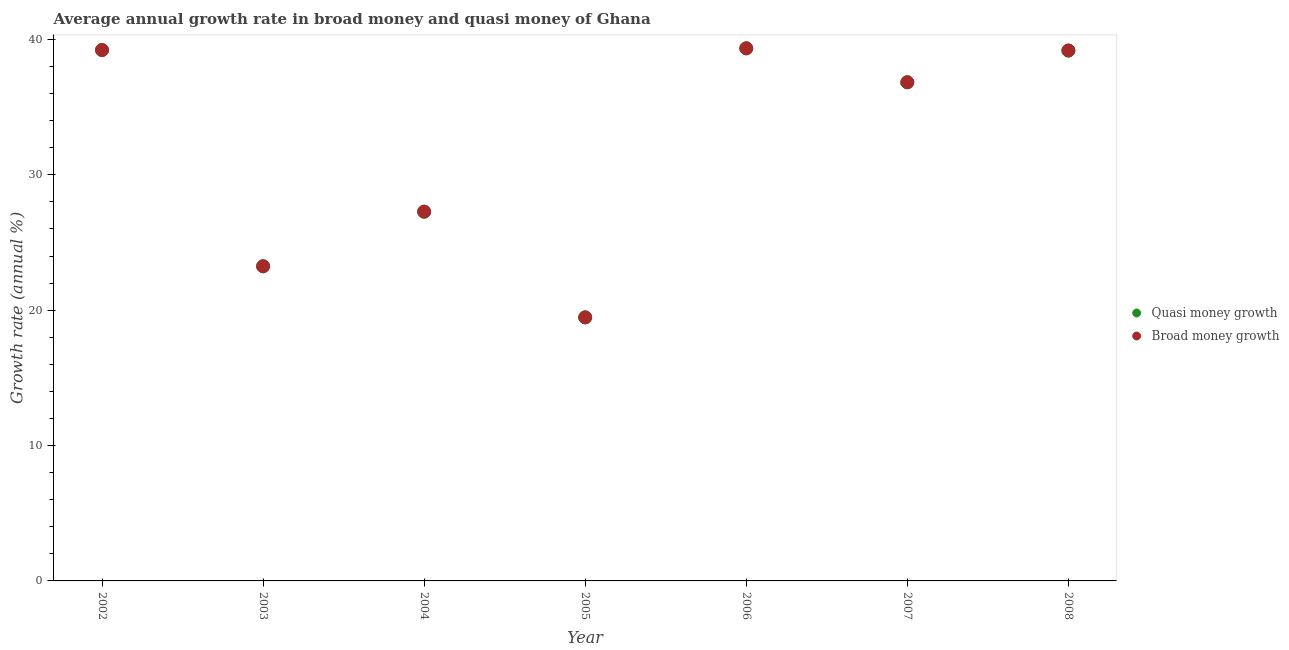How many different coloured dotlines are there?
Offer a very short reply. 2. Is the number of dotlines equal to the number of legend labels?
Offer a terse response. Yes. What is the annual growth rate in quasi money in 2003?
Make the answer very short. 23.24. Across all years, what is the maximum annual growth rate in broad money?
Offer a very short reply. 39.34. Across all years, what is the minimum annual growth rate in quasi money?
Offer a very short reply. 19.47. In which year was the annual growth rate in broad money maximum?
Keep it short and to the point. 2006. What is the total annual growth rate in quasi money in the graph?
Offer a terse response. 224.55. What is the difference between the annual growth rate in broad money in 2006 and that in 2008?
Provide a succinct answer. 0.16. What is the difference between the annual growth rate in quasi money in 2006 and the annual growth rate in broad money in 2008?
Offer a very short reply. 0.16. What is the average annual growth rate in quasi money per year?
Offer a terse response. 32.08. In the year 2005, what is the difference between the annual growth rate in broad money and annual growth rate in quasi money?
Make the answer very short. 0. What is the ratio of the annual growth rate in quasi money in 2005 to that in 2007?
Your answer should be very brief. 0.53. Is the difference between the annual growth rate in quasi money in 2005 and 2006 greater than the difference between the annual growth rate in broad money in 2005 and 2006?
Offer a terse response. No. What is the difference between the highest and the second highest annual growth rate in quasi money?
Offer a very short reply. 0.13. What is the difference between the highest and the lowest annual growth rate in quasi money?
Your answer should be compact. 19.87. In how many years, is the annual growth rate in quasi money greater than the average annual growth rate in quasi money taken over all years?
Ensure brevity in your answer.  4. Is the annual growth rate in broad money strictly greater than the annual growth rate in quasi money over the years?
Make the answer very short. No. Is the annual growth rate in quasi money strictly less than the annual growth rate in broad money over the years?
Make the answer very short. No. How many dotlines are there?
Keep it short and to the point. 2. How many years are there in the graph?
Your response must be concise. 7. Does the graph contain grids?
Your answer should be very brief. No. Where does the legend appear in the graph?
Your response must be concise. Center right. What is the title of the graph?
Provide a succinct answer. Average annual growth rate in broad money and quasi money of Ghana. What is the label or title of the X-axis?
Offer a terse response. Year. What is the label or title of the Y-axis?
Give a very brief answer. Growth rate (annual %). What is the Growth rate (annual %) in Quasi money growth in 2002?
Make the answer very short. 39.21. What is the Growth rate (annual %) in Broad money growth in 2002?
Ensure brevity in your answer.  39.21. What is the Growth rate (annual %) in Quasi money growth in 2003?
Give a very brief answer. 23.24. What is the Growth rate (annual %) in Broad money growth in 2003?
Provide a succinct answer. 23.24. What is the Growth rate (annual %) in Quasi money growth in 2004?
Ensure brevity in your answer.  27.28. What is the Growth rate (annual %) of Broad money growth in 2004?
Provide a succinct answer. 27.28. What is the Growth rate (annual %) of Quasi money growth in 2005?
Offer a terse response. 19.47. What is the Growth rate (annual %) of Broad money growth in 2005?
Your answer should be very brief. 19.47. What is the Growth rate (annual %) of Quasi money growth in 2006?
Your response must be concise. 39.34. What is the Growth rate (annual %) of Broad money growth in 2006?
Keep it short and to the point. 39.34. What is the Growth rate (annual %) in Quasi money growth in 2007?
Provide a short and direct response. 36.83. What is the Growth rate (annual %) of Broad money growth in 2007?
Your response must be concise. 36.83. What is the Growth rate (annual %) of Quasi money growth in 2008?
Ensure brevity in your answer.  39.18. What is the Growth rate (annual %) of Broad money growth in 2008?
Offer a terse response. 39.18. Across all years, what is the maximum Growth rate (annual %) of Quasi money growth?
Your response must be concise. 39.34. Across all years, what is the maximum Growth rate (annual %) of Broad money growth?
Keep it short and to the point. 39.34. Across all years, what is the minimum Growth rate (annual %) in Quasi money growth?
Provide a short and direct response. 19.47. Across all years, what is the minimum Growth rate (annual %) of Broad money growth?
Provide a short and direct response. 19.47. What is the total Growth rate (annual %) of Quasi money growth in the graph?
Your answer should be compact. 224.55. What is the total Growth rate (annual %) in Broad money growth in the graph?
Ensure brevity in your answer.  224.55. What is the difference between the Growth rate (annual %) in Quasi money growth in 2002 and that in 2003?
Your response must be concise. 15.97. What is the difference between the Growth rate (annual %) in Broad money growth in 2002 and that in 2003?
Offer a very short reply. 15.97. What is the difference between the Growth rate (annual %) of Quasi money growth in 2002 and that in 2004?
Offer a very short reply. 11.94. What is the difference between the Growth rate (annual %) of Broad money growth in 2002 and that in 2004?
Your response must be concise. 11.94. What is the difference between the Growth rate (annual %) in Quasi money growth in 2002 and that in 2005?
Give a very brief answer. 19.75. What is the difference between the Growth rate (annual %) of Broad money growth in 2002 and that in 2005?
Give a very brief answer. 19.75. What is the difference between the Growth rate (annual %) in Quasi money growth in 2002 and that in 2006?
Keep it short and to the point. -0.13. What is the difference between the Growth rate (annual %) in Broad money growth in 2002 and that in 2006?
Keep it short and to the point. -0.13. What is the difference between the Growth rate (annual %) in Quasi money growth in 2002 and that in 2007?
Keep it short and to the point. 2.38. What is the difference between the Growth rate (annual %) of Broad money growth in 2002 and that in 2007?
Provide a short and direct response. 2.38. What is the difference between the Growth rate (annual %) of Quasi money growth in 2002 and that in 2008?
Make the answer very short. 0.04. What is the difference between the Growth rate (annual %) in Broad money growth in 2002 and that in 2008?
Provide a succinct answer. 0.04. What is the difference between the Growth rate (annual %) in Quasi money growth in 2003 and that in 2004?
Your answer should be very brief. -4.03. What is the difference between the Growth rate (annual %) of Broad money growth in 2003 and that in 2004?
Give a very brief answer. -4.03. What is the difference between the Growth rate (annual %) in Quasi money growth in 2003 and that in 2005?
Keep it short and to the point. 3.77. What is the difference between the Growth rate (annual %) of Broad money growth in 2003 and that in 2005?
Your answer should be very brief. 3.77. What is the difference between the Growth rate (annual %) of Quasi money growth in 2003 and that in 2006?
Keep it short and to the point. -16.1. What is the difference between the Growth rate (annual %) in Broad money growth in 2003 and that in 2006?
Ensure brevity in your answer.  -16.1. What is the difference between the Growth rate (annual %) of Quasi money growth in 2003 and that in 2007?
Keep it short and to the point. -13.59. What is the difference between the Growth rate (annual %) in Broad money growth in 2003 and that in 2007?
Provide a short and direct response. -13.59. What is the difference between the Growth rate (annual %) of Quasi money growth in 2003 and that in 2008?
Give a very brief answer. -15.94. What is the difference between the Growth rate (annual %) in Broad money growth in 2003 and that in 2008?
Provide a short and direct response. -15.94. What is the difference between the Growth rate (annual %) in Quasi money growth in 2004 and that in 2005?
Give a very brief answer. 7.81. What is the difference between the Growth rate (annual %) of Broad money growth in 2004 and that in 2005?
Give a very brief answer. 7.81. What is the difference between the Growth rate (annual %) of Quasi money growth in 2004 and that in 2006?
Ensure brevity in your answer.  -12.07. What is the difference between the Growth rate (annual %) in Broad money growth in 2004 and that in 2006?
Offer a very short reply. -12.07. What is the difference between the Growth rate (annual %) in Quasi money growth in 2004 and that in 2007?
Offer a terse response. -9.56. What is the difference between the Growth rate (annual %) in Broad money growth in 2004 and that in 2007?
Give a very brief answer. -9.56. What is the difference between the Growth rate (annual %) of Quasi money growth in 2004 and that in 2008?
Your answer should be very brief. -11.9. What is the difference between the Growth rate (annual %) in Broad money growth in 2004 and that in 2008?
Your response must be concise. -11.9. What is the difference between the Growth rate (annual %) in Quasi money growth in 2005 and that in 2006?
Your answer should be very brief. -19.87. What is the difference between the Growth rate (annual %) of Broad money growth in 2005 and that in 2006?
Offer a terse response. -19.87. What is the difference between the Growth rate (annual %) in Quasi money growth in 2005 and that in 2007?
Provide a succinct answer. -17.37. What is the difference between the Growth rate (annual %) of Broad money growth in 2005 and that in 2007?
Provide a short and direct response. -17.37. What is the difference between the Growth rate (annual %) in Quasi money growth in 2005 and that in 2008?
Give a very brief answer. -19.71. What is the difference between the Growth rate (annual %) in Broad money growth in 2005 and that in 2008?
Your answer should be very brief. -19.71. What is the difference between the Growth rate (annual %) of Quasi money growth in 2006 and that in 2007?
Keep it short and to the point. 2.51. What is the difference between the Growth rate (annual %) in Broad money growth in 2006 and that in 2007?
Keep it short and to the point. 2.51. What is the difference between the Growth rate (annual %) of Quasi money growth in 2006 and that in 2008?
Give a very brief answer. 0.16. What is the difference between the Growth rate (annual %) in Broad money growth in 2006 and that in 2008?
Ensure brevity in your answer.  0.16. What is the difference between the Growth rate (annual %) in Quasi money growth in 2007 and that in 2008?
Keep it short and to the point. -2.34. What is the difference between the Growth rate (annual %) in Broad money growth in 2007 and that in 2008?
Make the answer very short. -2.34. What is the difference between the Growth rate (annual %) of Quasi money growth in 2002 and the Growth rate (annual %) of Broad money growth in 2003?
Keep it short and to the point. 15.97. What is the difference between the Growth rate (annual %) in Quasi money growth in 2002 and the Growth rate (annual %) in Broad money growth in 2004?
Offer a very short reply. 11.94. What is the difference between the Growth rate (annual %) in Quasi money growth in 2002 and the Growth rate (annual %) in Broad money growth in 2005?
Offer a very short reply. 19.75. What is the difference between the Growth rate (annual %) of Quasi money growth in 2002 and the Growth rate (annual %) of Broad money growth in 2006?
Keep it short and to the point. -0.13. What is the difference between the Growth rate (annual %) in Quasi money growth in 2002 and the Growth rate (annual %) in Broad money growth in 2007?
Offer a terse response. 2.38. What is the difference between the Growth rate (annual %) in Quasi money growth in 2002 and the Growth rate (annual %) in Broad money growth in 2008?
Give a very brief answer. 0.04. What is the difference between the Growth rate (annual %) of Quasi money growth in 2003 and the Growth rate (annual %) of Broad money growth in 2004?
Your answer should be compact. -4.03. What is the difference between the Growth rate (annual %) in Quasi money growth in 2003 and the Growth rate (annual %) in Broad money growth in 2005?
Make the answer very short. 3.77. What is the difference between the Growth rate (annual %) of Quasi money growth in 2003 and the Growth rate (annual %) of Broad money growth in 2006?
Provide a succinct answer. -16.1. What is the difference between the Growth rate (annual %) of Quasi money growth in 2003 and the Growth rate (annual %) of Broad money growth in 2007?
Your response must be concise. -13.59. What is the difference between the Growth rate (annual %) in Quasi money growth in 2003 and the Growth rate (annual %) in Broad money growth in 2008?
Give a very brief answer. -15.94. What is the difference between the Growth rate (annual %) of Quasi money growth in 2004 and the Growth rate (annual %) of Broad money growth in 2005?
Offer a very short reply. 7.81. What is the difference between the Growth rate (annual %) in Quasi money growth in 2004 and the Growth rate (annual %) in Broad money growth in 2006?
Provide a short and direct response. -12.07. What is the difference between the Growth rate (annual %) of Quasi money growth in 2004 and the Growth rate (annual %) of Broad money growth in 2007?
Your answer should be compact. -9.56. What is the difference between the Growth rate (annual %) of Quasi money growth in 2004 and the Growth rate (annual %) of Broad money growth in 2008?
Your answer should be very brief. -11.9. What is the difference between the Growth rate (annual %) of Quasi money growth in 2005 and the Growth rate (annual %) of Broad money growth in 2006?
Provide a succinct answer. -19.87. What is the difference between the Growth rate (annual %) in Quasi money growth in 2005 and the Growth rate (annual %) in Broad money growth in 2007?
Ensure brevity in your answer.  -17.37. What is the difference between the Growth rate (annual %) in Quasi money growth in 2005 and the Growth rate (annual %) in Broad money growth in 2008?
Offer a very short reply. -19.71. What is the difference between the Growth rate (annual %) of Quasi money growth in 2006 and the Growth rate (annual %) of Broad money growth in 2007?
Your answer should be compact. 2.51. What is the difference between the Growth rate (annual %) in Quasi money growth in 2006 and the Growth rate (annual %) in Broad money growth in 2008?
Make the answer very short. 0.16. What is the difference between the Growth rate (annual %) of Quasi money growth in 2007 and the Growth rate (annual %) of Broad money growth in 2008?
Give a very brief answer. -2.34. What is the average Growth rate (annual %) in Quasi money growth per year?
Ensure brevity in your answer.  32.08. What is the average Growth rate (annual %) in Broad money growth per year?
Keep it short and to the point. 32.08. In the year 2004, what is the difference between the Growth rate (annual %) of Quasi money growth and Growth rate (annual %) of Broad money growth?
Provide a short and direct response. 0. In the year 2005, what is the difference between the Growth rate (annual %) of Quasi money growth and Growth rate (annual %) of Broad money growth?
Ensure brevity in your answer.  0. In the year 2006, what is the difference between the Growth rate (annual %) of Quasi money growth and Growth rate (annual %) of Broad money growth?
Keep it short and to the point. 0. In the year 2007, what is the difference between the Growth rate (annual %) of Quasi money growth and Growth rate (annual %) of Broad money growth?
Offer a terse response. 0. In the year 2008, what is the difference between the Growth rate (annual %) in Quasi money growth and Growth rate (annual %) in Broad money growth?
Offer a terse response. 0. What is the ratio of the Growth rate (annual %) of Quasi money growth in 2002 to that in 2003?
Provide a succinct answer. 1.69. What is the ratio of the Growth rate (annual %) of Broad money growth in 2002 to that in 2003?
Give a very brief answer. 1.69. What is the ratio of the Growth rate (annual %) in Quasi money growth in 2002 to that in 2004?
Keep it short and to the point. 1.44. What is the ratio of the Growth rate (annual %) in Broad money growth in 2002 to that in 2004?
Make the answer very short. 1.44. What is the ratio of the Growth rate (annual %) of Quasi money growth in 2002 to that in 2005?
Your answer should be compact. 2.01. What is the ratio of the Growth rate (annual %) in Broad money growth in 2002 to that in 2005?
Offer a very short reply. 2.01. What is the ratio of the Growth rate (annual %) of Quasi money growth in 2002 to that in 2006?
Provide a succinct answer. 1. What is the ratio of the Growth rate (annual %) of Quasi money growth in 2002 to that in 2007?
Offer a terse response. 1.06. What is the ratio of the Growth rate (annual %) of Broad money growth in 2002 to that in 2007?
Your answer should be very brief. 1.06. What is the ratio of the Growth rate (annual %) of Quasi money growth in 2002 to that in 2008?
Give a very brief answer. 1. What is the ratio of the Growth rate (annual %) of Quasi money growth in 2003 to that in 2004?
Provide a short and direct response. 0.85. What is the ratio of the Growth rate (annual %) in Broad money growth in 2003 to that in 2004?
Ensure brevity in your answer.  0.85. What is the ratio of the Growth rate (annual %) in Quasi money growth in 2003 to that in 2005?
Your answer should be very brief. 1.19. What is the ratio of the Growth rate (annual %) in Broad money growth in 2003 to that in 2005?
Offer a very short reply. 1.19. What is the ratio of the Growth rate (annual %) of Quasi money growth in 2003 to that in 2006?
Provide a succinct answer. 0.59. What is the ratio of the Growth rate (annual %) in Broad money growth in 2003 to that in 2006?
Provide a succinct answer. 0.59. What is the ratio of the Growth rate (annual %) in Quasi money growth in 2003 to that in 2007?
Provide a short and direct response. 0.63. What is the ratio of the Growth rate (annual %) in Broad money growth in 2003 to that in 2007?
Your answer should be very brief. 0.63. What is the ratio of the Growth rate (annual %) in Quasi money growth in 2003 to that in 2008?
Keep it short and to the point. 0.59. What is the ratio of the Growth rate (annual %) of Broad money growth in 2003 to that in 2008?
Your answer should be very brief. 0.59. What is the ratio of the Growth rate (annual %) in Quasi money growth in 2004 to that in 2005?
Keep it short and to the point. 1.4. What is the ratio of the Growth rate (annual %) of Broad money growth in 2004 to that in 2005?
Ensure brevity in your answer.  1.4. What is the ratio of the Growth rate (annual %) of Quasi money growth in 2004 to that in 2006?
Your response must be concise. 0.69. What is the ratio of the Growth rate (annual %) of Broad money growth in 2004 to that in 2006?
Make the answer very short. 0.69. What is the ratio of the Growth rate (annual %) of Quasi money growth in 2004 to that in 2007?
Your answer should be compact. 0.74. What is the ratio of the Growth rate (annual %) of Broad money growth in 2004 to that in 2007?
Offer a very short reply. 0.74. What is the ratio of the Growth rate (annual %) of Quasi money growth in 2004 to that in 2008?
Your answer should be compact. 0.7. What is the ratio of the Growth rate (annual %) of Broad money growth in 2004 to that in 2008?
Your answer should be very brief. 0.7. What is the ratio of the Growth rate (annual %) of Quasi money growth in 2005 to that in 2006?
Make the answer very short. 0.49. What is the ratio of the Growth rate (annual %) in Broad money growth in 2005 to that in 2006?
Provide a short and direct response. 0.49. What is the ratio of the Growth rate (annual %) of Quasi money growth in 2005 to that in 2007?
Provide a short and direct response. 0.53. What is the ratio of the Growth rate (annual %) of Broad money growth in 2005 to that in 2007?
Your response must be concise. 0.53. What is the ratio of the Growth rate (annual %) in Quasi money growth in 2005 to that in 2008?
Ensure brevity in your answer.  0.5. What is the ratio of the Growth rate (annual %) of Broad money growth in 2005 to that in 2008?
Keep it short and to the point. 0.5. What is the ratio of the Growth rate (annual %) of Quasi money growth in 2006 to that in 2007?
Offer a terse response. 1.07. What is the ratio of the Growth rate (annual %) in Broad money growth in 2006 to that in 2007?
Your answer should be very brief. 1.07. What is the ratio of the Growth rate (annual %) in Quasi money growth in 2007 to that in 2008?
Provide a succinct answer. 0.94. What is the ratio of the Growth rate (annual %) of Broad money growth in 2007 to that in 2008?
Keep it short and to the point. 0.94. What is the difference between the highest and the second highest Growth rate (annual %) of Quasi money growth?
Your answer should be compact. 0.13. What is the difference between the highest and the second highest Growth rate (annual %) in Broad money growth?
Provide a short and direct response. 0.13. What is the difference between the highest and the lowest Growth rate (annual %) in Quasi money growth?
Keep it short and to the point. 19.87. What is the difference between the highest and the lowest Growth rate (annual %) of Broad money growth?
Your answer should be compact. 19.87. 